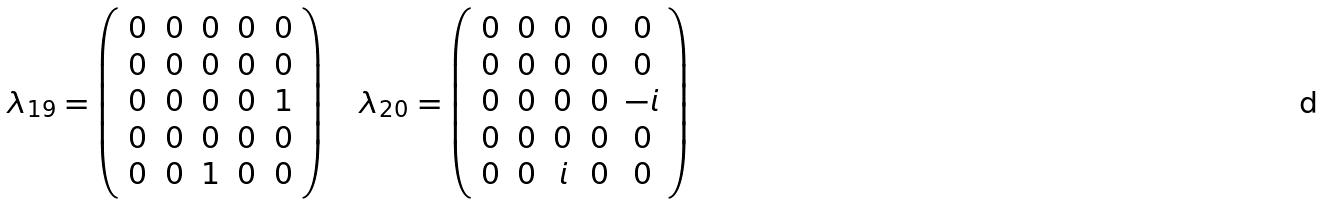Convert formula to latex. <formula><loc_0><loc_0><loc_500><loc_500>\lambda _ { 1 9 } = \left ( \begin{array} { c c c c c } 0 & 0 & 0 & 0 & 0 \\ 0 & 0 & 0 & 0 & 0 \\ 0 & 0 & 0 & 0 & 1 \\ 0 & 0 & 0 & 0 & 0 \\ 0 & 0 & 1 & 0 & 0 \end{array} \right ) \quad \lambda _ { 2 0 } = \left ( \begin{array} { c c c c c } 0 & 0 & 0 & 0 & 0 \\ 0 & 0 & 0 & 0 & 0 \\ 0 & 0 & 0 & 0 & - i \\ 0 & 0 & 0 & 0 & 0 \\ 0 & 0 & i & 0 & 0 \end{array} \right )</formula> 